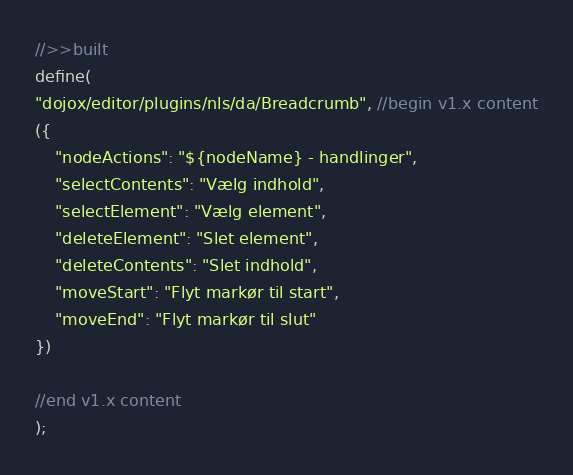<code> <loc_0><loc_0><loc_500><loc_500><_JavaScript_>//>>built
define(
"dojox/editor/plugins/nls/da/Breadcrumb", //begin v1.x content
({
	"nodeActions": "${nodeName} - handlinger",
	"selectContents": "Vælg indhold",
	"selectElement": "Vælg element",
	"deleteElement": "Slet element",
	"deleteContents": "Slet indhold",
	"moveStart": "Flyt markør til start",
	"moveEnd": "Flyt markør til slut"
})

//end v1.x content
);
</code> 